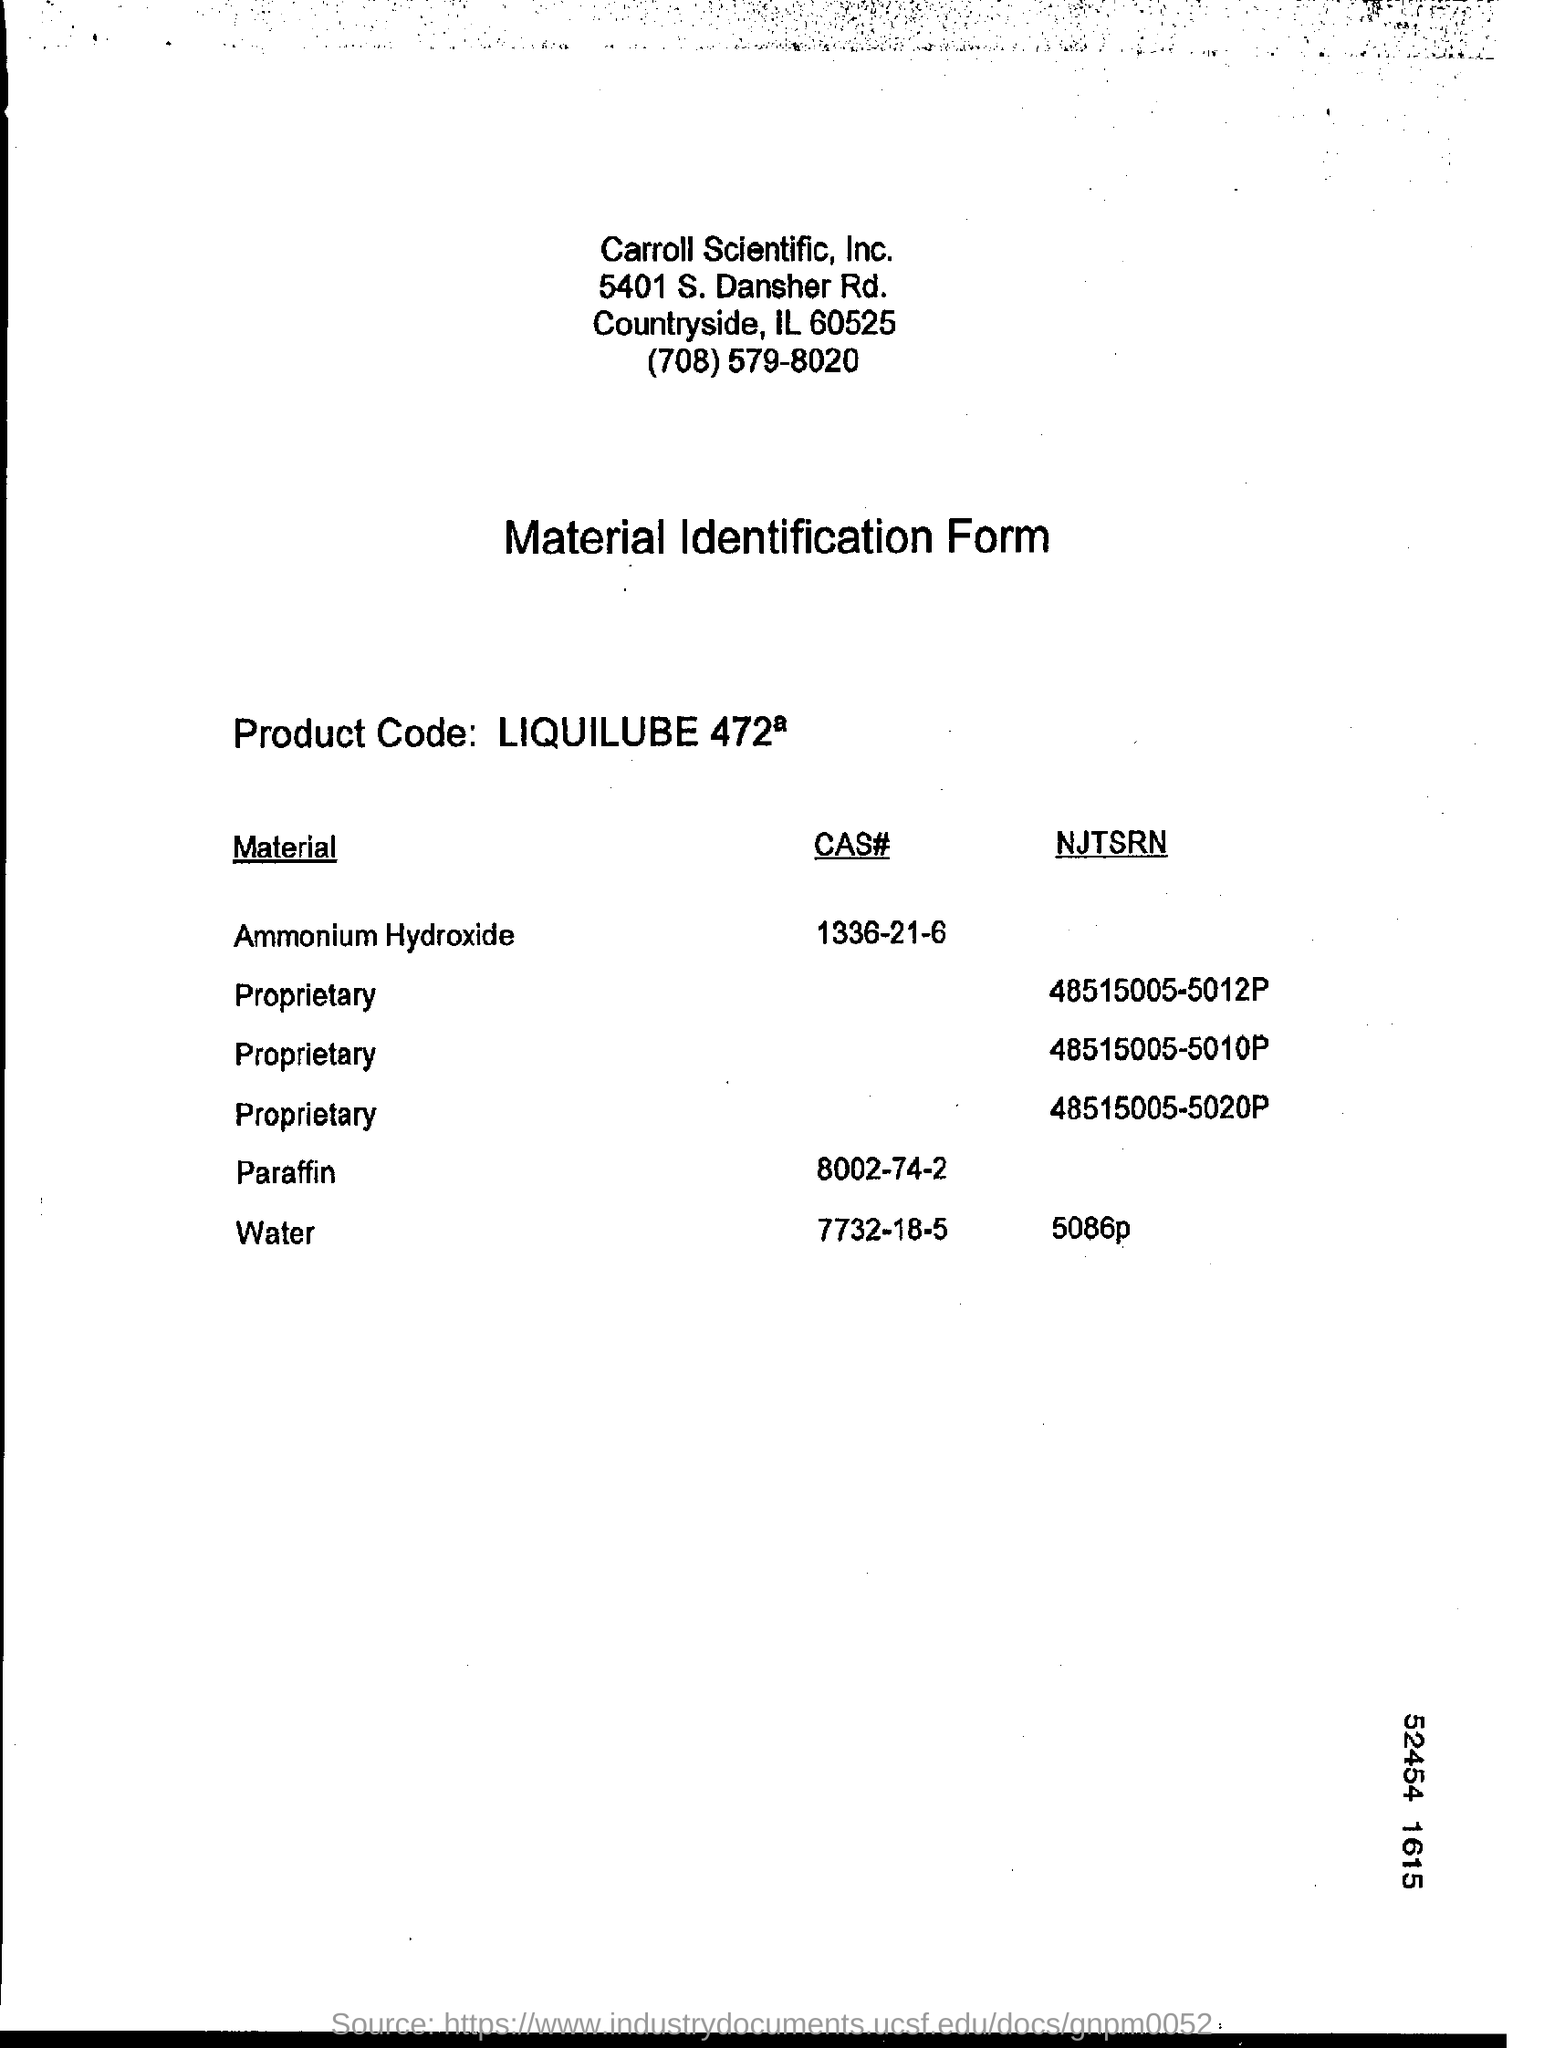What is NJTSRN of Water
Offer a very short reply. 5086p. 